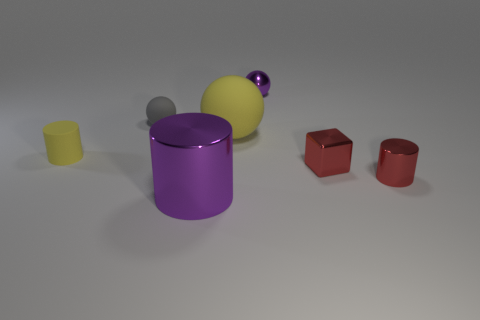What is the shape of the metallic object that is the same color as the big cylinder?
Offer a terse response. Sphere. How many other objects have the same shape as the large metallic object?
Offer a terse response. 2. There is a metal thing behind the yellow object that is right of the purple metallic cylinder; how big is it?
Keep it short and to the point. Small. How many brown objects are either tiny spheres or spheres?
Keep it short and to the point. 0. Is the number of tiny shiny spheres that are on the left side of the big cylinder less than the number of tiny cylinders right of the large sphere?
Make the answer very short. Yes. There is a purple metal cylinder; does it have the same size as the purple metal object behind the small matte cylinder?
Ensure brevity in your answer.  No. How many blue rubber things have the same size as the purple sphere?
Offer a terse response. 0. What number of tiny things are rubber cylinders or red shiny objects?
Your response must be concise. 3. Are any tiny gray metallic cylinders visible?
Provide a short and direct response. No. Is the number of purple metallic spheres that are to the right of the cube greater than the number of balls that are left of the small rubber cylinder?
Your answer should be compact. No. 